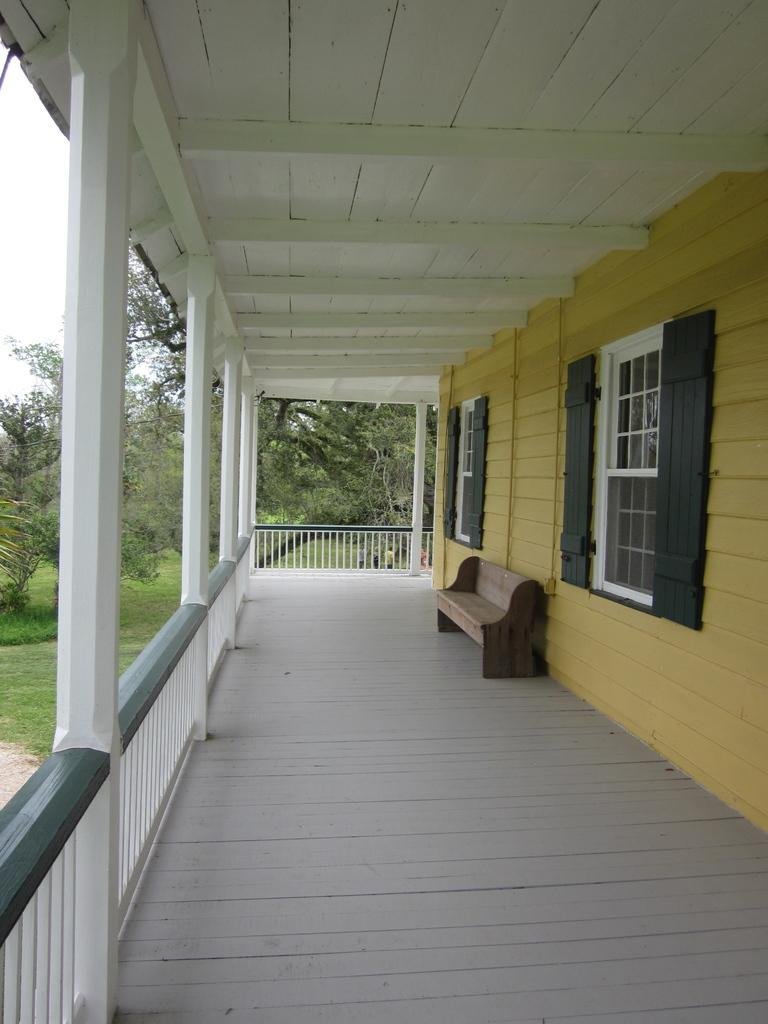What type of architectural feature can be seen in the image? There are windows and a bench visible in the image. What type of structure is present in the image? There is a house in the image. What type of security feature is present in the image? There are iron grills in the image. What type of vegetation is present in the image? There are trees in the image. What part of the natural environment is visible in the image? The sky is visible in the image. What type of scent can be detected in the image? There is no information about any scent in the image. What is the size of the house in the image? The size of the house cannot be determined from the image alone. 